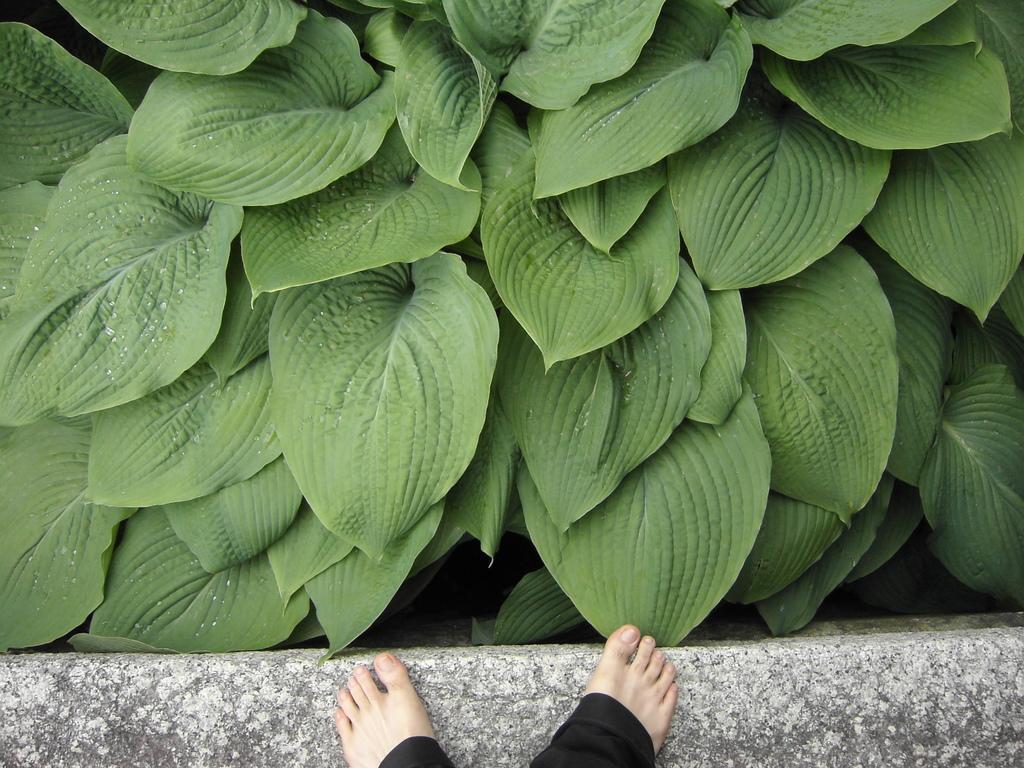Could you give a brief overview of what you see in this image? At the bottom of the image there is a small wall with the toes of a person. And there are green leaves. 